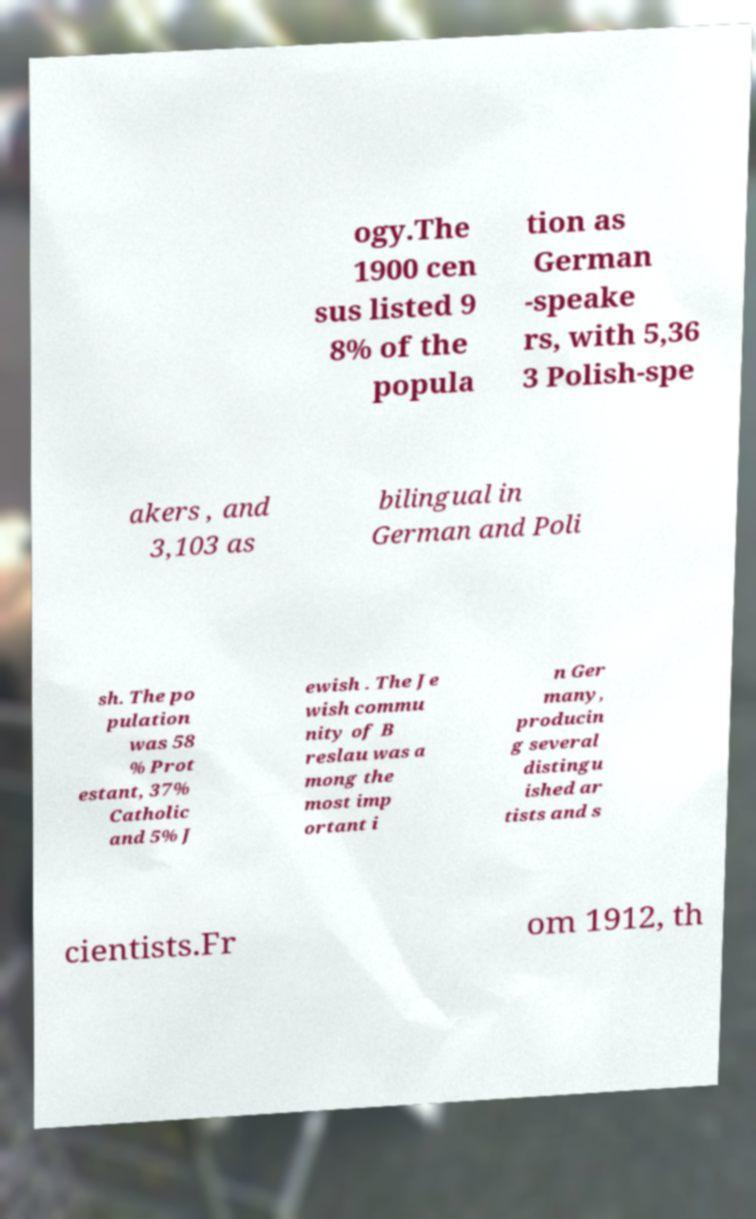Can you accurately transcribe the text from the provided image for me? ogy.The 1900 cen sus listed 9 8% of the popula tion as German -speake rs, with 5,36 3 Polish-spe akers , and 3,103 as bilingual in German and Poli sh. The po pulation was 58 % Prot estant, 37% Catholic and 5% J ewish . The Je wish commu nity of B reslau was a mong the most imp ortant i n Ger many, producin g several distingu ished ar tists and s cientists.Fr om 1912, th 